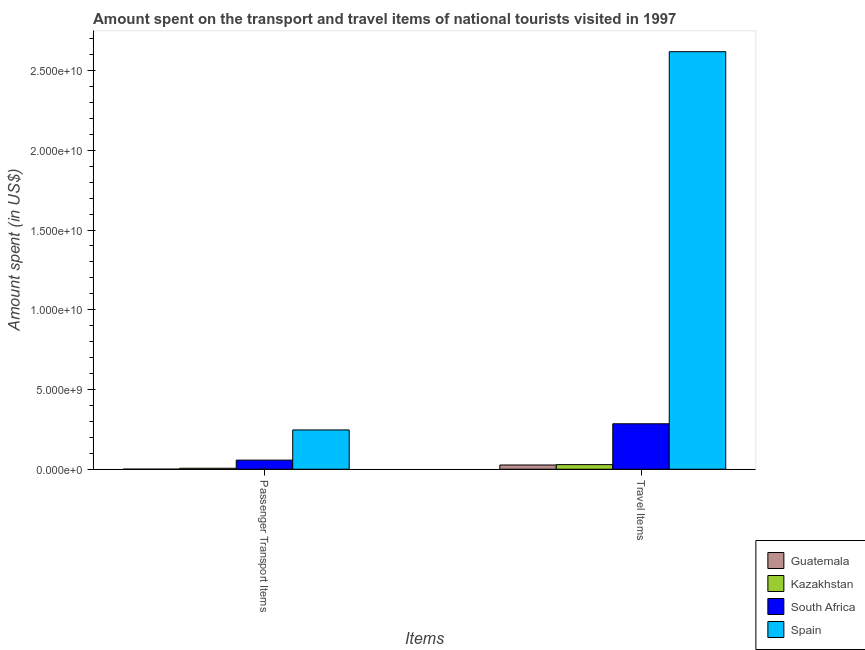How many different coloured bars are there?
Your answer should be very brief. 4. Are the number of bars per tick equal to the number of legend labels?
Give a very brief answer. Yes. Are the number of bars on each tick of the X-axis equal?
Your answer should be very brief. Yes. How many bars are there on the 1st tick from the left?
Provide a short and direct response. 4. What is the label of the 1st group of bars from the left?
Ensure brevity in your answer.  Passenger Transport Items. What is the amount spent on passenger transport items in South Africa?
Your answer should be very brief. 5.71e+08. Across all countries, what is the maximum amount spent in travel items?
Your response must be concise. 2.62e+1. Across all countries, what is the minimum amount spent in travel items?
Your answer should be compact. 2.66e+08. In which country was the amount spent on passenger transport items maximum?
Offer a very short reply. Spain. In which country was the amount spent in travel items minimum?
Keep it short and to the point. Guatemala. What is the total amount spent on passenger transport items in the graph?
Your response must be concise. 3.10e+09. What is the difference between the amount spent in travel items in Kazakhstan and that in South Africa?
Provide a short and direct response. -2.56e+09. What is the difference between the amount spent on passenger transport items in Guatemala and the amount spent in travel items in Spain?
Offer a very short reply. -2.62e+1. What is the average amount spent on passenger transport items per country?
Ensure brevity in your answer.  7.75e+08. What is the difference between the amount spent on passenger transport items and amount spent in travel items in South Africa?
Your answer should be very brief. -2.28e+09. What is the ratio of the amount spent on passenger transport items in Spain to that in South Africa?
Make the answer very short. 4.32. In how many countries, is the amount spent in travel items greater than the average amount spent in travel items taken over all countries?
Offer a very short reply. 1. What does the 3rd bar from the left in Travel Items represents?
Give a very brief answer. South Africa. What does the 1st bar from the right in Passenger Transport Items represents?
Your answer should be very brief. Spain. Are all the bars in the graph horizontal?
Ensure brevity in your answer.  No. What is the difference between two consecutive major ticks on the Y-axis?
Your answer should be compact. 5.00e+09. How many legend labels are there?
Your answer should be compact. 4. How are the legend labels stacked?
Your answer should be compact. Vertical. What is the title of the graph?
Provide a short and direct response. Amount spent on the transport and travel items of national tourists visited in 1997. Does "Algeria" appear as one of the legend labels in the graph?
Give a very brief answer. No. What is the label or title of the X-axis?
Make the answer very short. Items. What is the label or title of the Y-axis?
Give a very brief answer. Amount spent (in US$). What is the Amount spent (in US$) in Kazakhstan in Passenger Transport Items?
Provide a short and direct response. 6.10e+07. What is the Amount spent (in US$) of South Africa in Passenger Transport Items?
Your answer should be very brief. 5.71e+08. What is the Amount spent (in US$) of Spain in Passenger Transport Items?
Your answer should be very brief. 2.46e+09. What is the Amount spent (in US$) in Guatemala in Travel Items?
Make the answer very short. 2.66e+08. What is the Amount spent (in US$) in Kazakhstan in Travel Items?
Provide a short and direct response. 2.89e+08. What is the Amount spent (in US$) in South Africa in Travel Items?
Ensure brevity in your answer.  2.85e+09. What is the Amount spent (in US$) of Spain in Travel Items?
Offer a terse response. 2.62e+1. Across all Items, what is the maximum Amount spent (in US$) of Guatemala?
Your answer should be very brief. 2.66e+08. Across all Items, what is the maximum Amount spent (in US$) of Kazakhstan?
Give a very brief answer. 2.89e+08. Across all Items, what is the maximum Amount spent (in US$) of South Africa?
Your answer should be compact. 2.85e+09. Across all Items, what is the maximum Amount spent (in US$) in Spain?
Offer a terse response. 2.62e+1. Across all Items, what is the minimum Amount spent (in US$) in Kazakhstan?
Provide a short and direct response. 6.10e+07. Across all Items, what is the minimum Amount spent (in US$) of South Africa?
Offer a terse response. 5.71e+08. Across all Items, what is the minimum Amount spent (in US$) of Spain?
Your answer should be very brief. 2.46e+09. What is the total Amount spent (in US$) in Guatemala in the graph?
Offer a very short reply. 2.70e+08. What is the total Amount spent (in US$) in Kazakhstan in the graph?
Ensure brevity in your answer.  3.50e+08. What is the total Amount spent (in US$) of South Africa in the graph?
Provide a succinct answer. 3.42e+09. What is the total Amount spent (in US$) of Spain in the graph?
Provide a succinct answer. 2.86e+1. What is the difference between the Amount spent (in US$) of Guatemala in Passenger Transport Items and that in Travel Items?
Provide a succinct answer. -2.62e+08. What is the difference between the Amount spent (in US$) in Kazakhstan in Passenger Transport Items and that in Travel Items?
Keep it short and to the point. -2.28e+08. What is the difference between the Amount spent (in US$) in South Africa in Passenger Transport Items and that in Travel Items?
Keep it short and to the point. -2.28e+09. What is the difference between the Amount spent (in US$) of Spain in Passenger Transport Items and that in Travel Items?
Ensure brevity in your answer.  -2.37e+1. What is the difference between the Amount spent (in US$) of Guatemala in Passenger Transport Items and the Amount spent (in US$) of Kazakhstan in Travel Items?
Offer a terse response. -2.85e+08. What is the difference between the Amount spent (in US$) of Guatemala in Passenger Transport Items and the Amount spent (in US$) of South Africa in Travel Items?
Keep it short and to the point. -2.85e+09. What is the difference between the Amount spent (in US$) in Guatemala in Passenger Transport Items and the Amount spent (in US$) in Spain in Travel Items?
Your answer should be very brief. -2.62e+1. What is the difference between the Amount spent (in US$) in Kazakhstan in Passenger Transport Items and the Amount spent (in US$) in South Africa in Travel Items?
Your response must be concise. -2.79e+09. What is the difference between the Amount spent (in US$) of Kazakhstan in Passenger Transport Items and the Amount spent (in US$) of Spain in Travel Items?
Give a very brief answer. -2.61e+1. What is the difference between the Amount spent (in US$) of South Africa in Passenger Transport Items and the Amount spent (in US$) of Spain in Travel Items?
Offer a terse response. -2.56e+1. What is the average Amount spent (in US$) in Guatemala per Items?
Keep it short and to the point. 1.35e+08. What is the average Amount spent (in US$) of Kazakhstan per Items?
Ensure brevity in your answer.  1.75e+08. What is the average Amount spent (in US$) of South Africa per Items?
Keep it short and to the point. 1.71e+09. What is the average Amount spent (in US$) of Spain per Items?
Your answer should be very brief. 1.43e+1. What is the difference between the Amount spent (in US$) of Guatemala and Amount spent (in US$) of Kazakhstan in Passenger Transport Items?
Give a very brief answer. -5.70e+07. What is the difference between the Amount spent (in US$) in Guatemala and Amount spent (in US$) in South Africa in Passenger Transport Items?
Ensure brevity in your answer.  -5.67e+08. What is the difference between the Amount spent (in US$) of Guatemala and Amount spent (in US$) of Spain in Passenger Transport Items?
Keep it short and to the point. -2.46e+09. What is the difference between the Amount spent (in US$) in Kazakhstan and Amount spent (in US$) in South Africa in Passenger Transport Items?
Make the answer very short. -5.10e+08. What is the difference between the Amount spent (in US$) in Kazakhstan and Amount spent (in US$) in Spain in Passenger Transport Items?
Provide a short and direct response. -2.40e+09. What is the difference between the Amount spent (in US$) in South Africa and Amount spent (in US$) in Spain in Passenger Transport Items?
Provide a succinct answer. -1.89e+09. What is the difference between the Amount spent (in US$) of Guatemala and Amount spent (in US$) of Kazakhstan in Travel Items?
Offer a terse response. -2.30e+07. What is the difference between the Amount spent (in US$) in Guatemala and Amount spent (in US$) in South Africa in Travel Items?
Offer a terse response. -2.58e+09. What is the difference between the Amount spent (in US$) of Guatemala and Amount spent (in US$) of Spain in Travel Items?
Provide a succinct answer. -2.59e+1. What is the difference between the Amount spent (in US$) of Kazakhstan and Amount spent (in US$) of South Africa in Travel Items?
Your response must be concise. -2.56e+09. What is the difference between the Amount spent (in US$) of Kazakhstan and Amount spent (in US$) of Spain in Travel Items?
Your answer should be very brief. -2.59e+1. What is the difference between the Amount spent (in US$) in South Africa and Amount spent (in US$) in Spain in Travel Items?
Offer a very short reply. -2.33e+1. What is the ratio of the Amount spent (in US$) of Guatemala in Passenger Transport Items to that in Travel Items?
Provide a succinct answer. 0.01. What is the ratio of the Amount spent (in US$) in Kazakhstan in Passenger Transport Items to that in Travel Items?
Make the answer very short. 0.21. What is the ratio of the Amount spent (in US$) in South Africa in Passenger Transport Items to that in Travel Items?
Keep it short and to the point. 0.2. What is the ratio of the Amount spent (in US$) in Spain in Passenger Transport Items to that in Travel Items?
Your answer should be compact. 0.09. What is the difference between the highest and the second highest Amount spent (in US$) in Guatemala?
Your answer should be very brief. 2.62e+08. What is the difference between the highest and the second highest Amount spent (in US$) of Kazakhstan?
Make the answer very short. 2.28e+08. What is the difference between the highest and the second highest Amount spent (in US$) of South Africa?
Offer a terse response. 2.28e+09. What is the difference between the highest and the second highest Amount spent (in US$) in Spain?
Provide a succinct answer. 2.37e+1. What is the difference between the highest and the lowest Amount spent (in US$) in Guatemala?
Keep it short and to the point. 2.62e+08. What is the difference between the highest and the lowest Amount spent (in US$) of Kazakhstan?
Keep it short and to the point. 2.28e+08. What is the difference between the highest and the lowest Amount spent (in US$) of South Africa?
Give a very brief answer. 2.28e+09. What is the difference between the highest and the lowest Amount spent (in US$) in Spain?
Offer a terse response. 2.37e+1. 